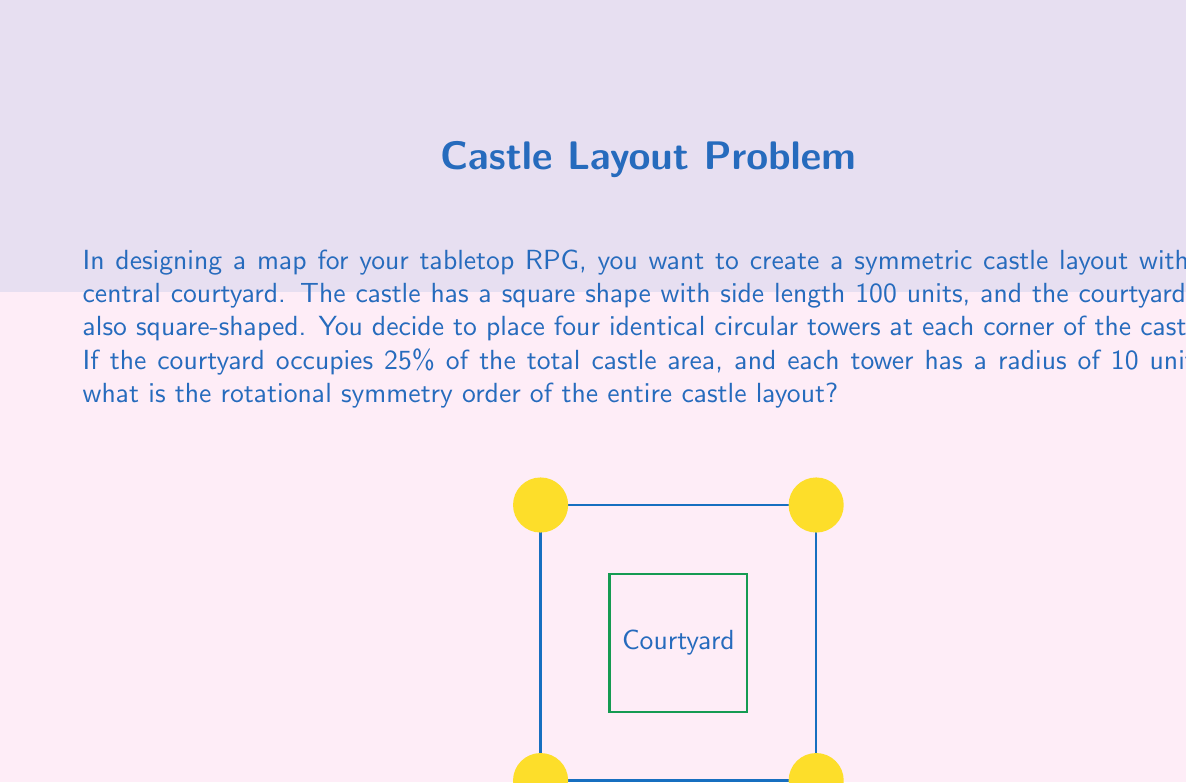Show me your answer to this math problem. Let's approach this step-by-step:

1) First, we need to understand what rotational symmetry means. A figure has rotational symmetry of order n if it can be rotated by 360°/n and appear unchanged.

2) Now, let's analyze the components of our castle:
   - The outer square (the castle walls)
   - The inner square (the courtyard)
   - Four circular towers at the corners

3) We're told that the courtyard occupies 25% of the total castle area. This means that the courtyard and the towers' positions are symmetrical about the center of the castle.

4) The square shape of both the castle and the courtyard has rotational symmetry of order 4. This means it can be rotated by 90°, 180°, 270°, and 360° to appear the same.

5) The circular towers are identical and placed at each corner. They also have rotational symmetry of order 4 with respect to the castle's center.

6) When we combine all these elements, we find that the entire layout maintains the rotational symmetry of order 4. This is because:
   - Rotating by 90° brings each tower to the position of the next tower
   - The square shapes of the castle and courtyard also align after a 90° rotation

7) Therefore, the rotational symmetry order of the entire castle layout is 4.

Note: The actual sizes of the courtyard and towers don't affect the rotational symmetry in this case, as long as they're symmetrically placed.
Answer: 4 